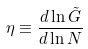<formula> <loc_0><loc_0><loc_500><loc_500>\eta \equiv \frac { d \ln \tilde { G } } { d \ln N }</formula> 